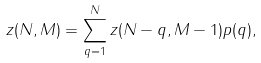Convert formula to latex. <formula><loc_0><loc_0><loc_500><loc_500>z ( N , M ) = \sum _ { q = 1 } ^ { N } z ( N - q , M - 1 ) p ( q ) ,</formula> 